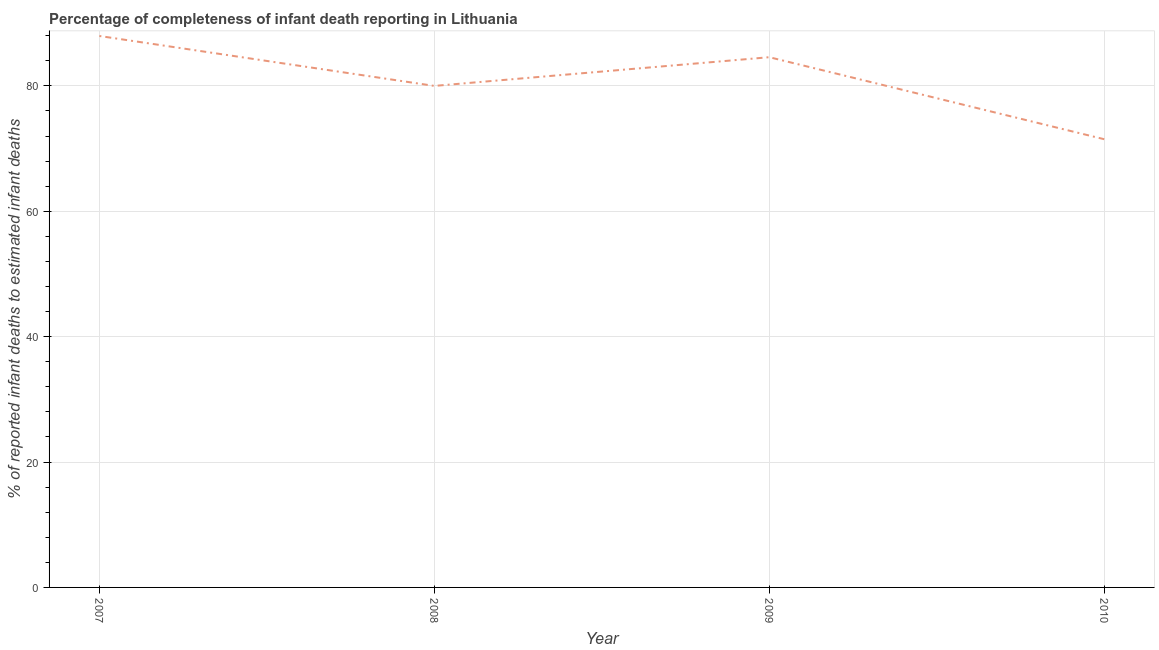What is the completeness of infant death reporting in 2009?
Offer a very short reply. 84.58. Across all years, what is the maximum completeness of infant death reporting?
Make the answer very short. 87.96. Across all years, what is the minimum completeness of infant death reporting?
Keep it short and to the point. 71.5. In which year was the completeness of infant death reporting maximum?
Ensure brevity in your answer.  2007. What is the sum of the completeness of infant death reporting?
Give a very brief answer. 324.04. What is the difference between the completeness of infant death reporting in 2008 and 2009?
Your answer should be very brief. -4.58. What is the average completeness of infant death reporting per year?
Provide a short and direct response. 81.01. What is the median completeness of infant death reporting?
Make the answer very short. 82.29. Do a majority of the years between 2009 and 2010 (inclusive) have completeness of infant death reporting greater than 84 %?
Keep it short and to the point. No. What is the ratio of the completeness of infant death reporting in 2008 to that in 2010?
Offer a very short reply. 1.12. What is the difference between the highest and the second highest completeness of infant death reporting?
Provide a short and direct response. 3.38. Is the sum of the completeness of infant death reporting in 2007 and 2009 greater than the maximum completeness of infant death reporting across all years?
Give a very brief answer. Yes. What is the difference between the highest and the lowest completeness of infant death reporting?
Offer a very short reply. 16.47. In how many years, is the completeness of infant death reporting greater than the average completeness of infant death reporting taken over all years?
Offer a very short reply. 2. How many years are there in the graph?
Ensure brevity in your answer.  4. Does the graph contain grids?
Your answer should be very brief. Yes. What is the title of the graph?
Offer a terse response. Percentage of completeness of infant death reporting in Lithuania. What is the label or title of the X-axis?
Your answer should be very brief. Year. What is the label or title of the Y-axis?
Keep it short and to the point. % of reported infant deaths to estimated infant deaths. What is the % of reported infant deaths to estimated infant deaths in 2007?
Make the answer very short. 87.96. What is the % of reported infant deaths to estimated infant deaths in 2008?
Your answer should be very brief. 80. What is the % of reported infant deaths to estimated infant deaths in 2009?
Your response must be concise. 84.58. What is the % of reported infant deaths to estimated infant deaths of 2010?
Keep it short and to the point. 71.5. What is the difference between the % of reported infant deaths to estimated infant deaths in 2007 and 2008?
Your answer should be very brief. 7.96. What is the difference between the % of reported infant deaths to estimated infant deaths in 2007 and 2009?
Provide a succinct answer. 3.38. What is the difference between the % of reported infant deaths to estimated infant deaths in 2007 and 2010?
Provide a short and direct response. 16.47. What is the difference between the % of reported infant deaths to estimated infant deaths in 2008 and 2009?
Your response must be concise. -4.58. What is the difference between the % of reported infant deaths to estimated infant deaths in 2008 and 2010?
Your answer should be very brief. 8.5. What is the difference between the % of reported infant deaths to estimated infant deaths in 2009 and 2010?
Keep it short and to the point. 13.08. What is the ratio of the % of reported infant deaths to estimated infant deaths in 2007 to that in 2009?
Your answer should be compact. 1.04. What is the ratio of the % of reported infant deaths to estimated infant deaths in 2007 to that in 2010?
Provide a short and direct response. 1.23. What is the ratio of the % of reported infant deaths to estimated infant deaths in 2008 to that in 2009?
Keep it short and to the point. 0.95. What is the ratio of the % of reported infant deaths to estimated infant deaths in 2008 to that in 2010?
Your answer should be very brief. 1.12. What is the ratio of the % of reported infant deaths to estimated infant deaths in 2009 to that in 2010?
Make the answer very short. 1.18. 